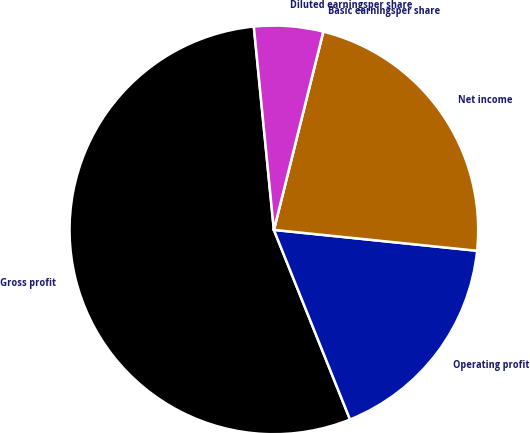<chart> <loc_0><loc_0><loc_500><loc_500><pie_chart><fcel>Gross profit<fcel>Operating profit<fcel>Net income<fcel>Basic earningsper share<fcel>Diluted earningsper share<nl><fcel>54.51%<fcel>17.29%<fcel>22.74%<fcel>0.0%<fcel>5.45%<nl></chart> 